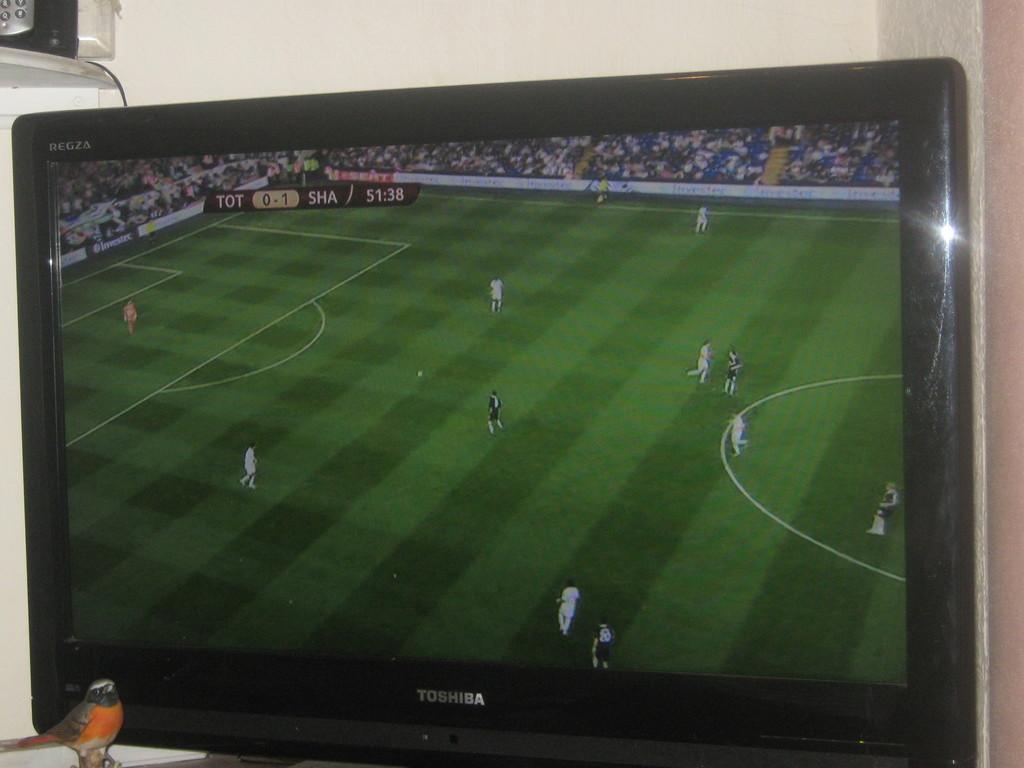What brand tv is this?
Give a very brief answer. Toshiba. 